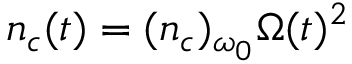<formula> <loc_0><loc_0><loc_500><loc_500>n _ { c } ( t ) = ( n _ { c } ) _ { \omega _ { 0 } } \Omega ( t ) ^ { 2 }</formula> 